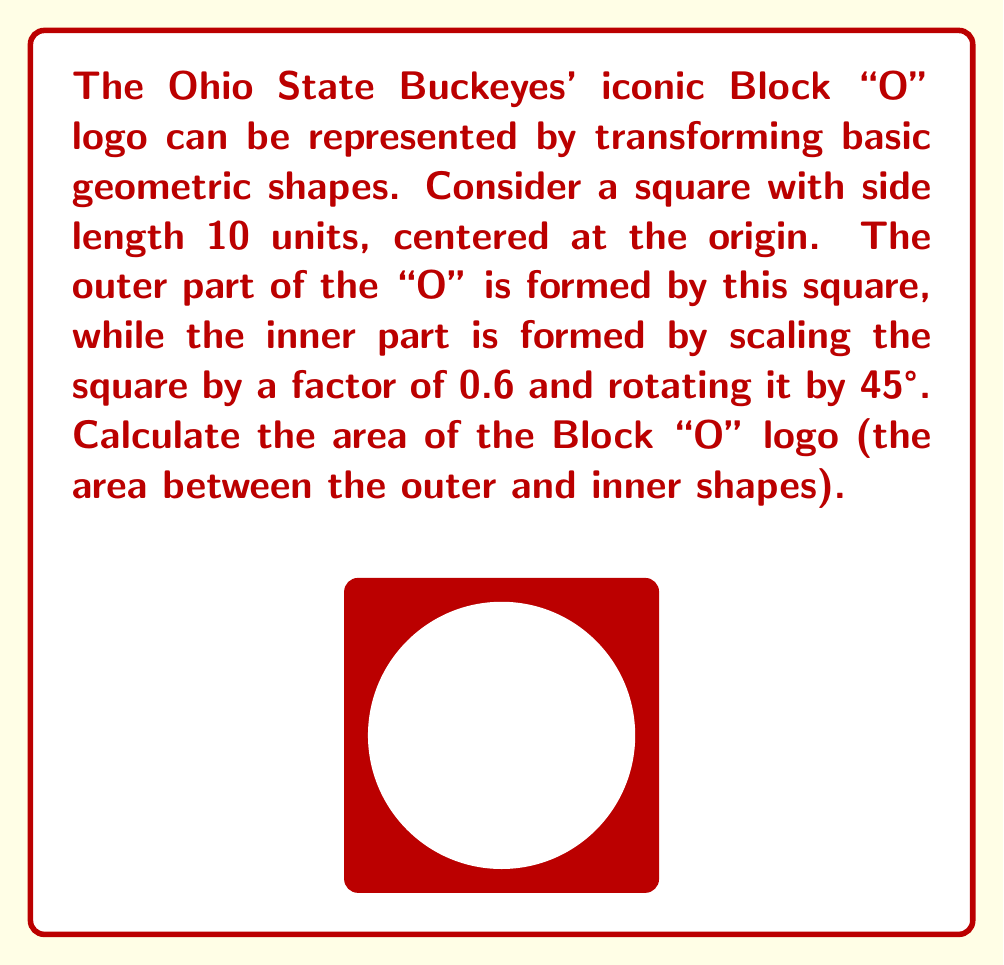Help me with this question. Let's approach this step-by-step:

1) The area of the Block "O" logo is the difference between the areas of the outer square and the rotated inner square.

2) Area of the outer square:
   $$A_{outer} = 10^2 = 100 \text{ square units}$$

3) For the inner square:
   a) Before rotation, its side length is: $10 * 0.6 = 6$ units
   b) Its area before rotation is: $6^2 = 36 \text{ square units}$
   c) Rotation doesn't change the area, so this remains the area of the inner square

4) The area of the Block "O" logo is:
   $$A_{logo} = A_{outer} - A_{inner} = 100 - 36 = 64 \text{ square units}$$

5) We can verify this result by calculating the area of the logo as a percentage of the outer square:
   $$\frac{A_{logo}}{A_{outer}} = \frac{64}{100} = 0.64 = 64\%$$

   This matches the fact that the inner square was scaled by a factor of 0.6, leaving 64% of the area for the logo.
Answer: $64 \text{ square units}$ 